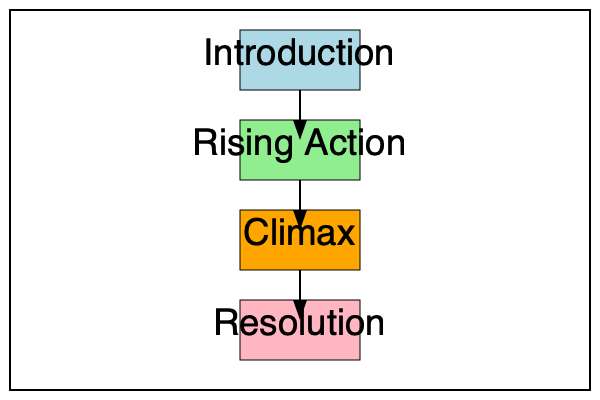Based on the flow chart provided, which storytelling element is missing from the classic narrative structure, and where should it be placed to create a complete and effective storytelling framework? To answer this question, let's analyze the flow chart and compare it to the classic narrative structure:

1. The flow chart shows four elements:
   a. Introduction
   b. Rising Action
   c. Climax
   d. Resolution

2. The classic narrative structure, also known as Freytag's Pyramid or the Five-Act Structure, typically includes five main elements:
   a. Exposition (Introduction)
   b. Rising Action
   c. Climax
   d. Falling Action
   e. Resolution (Denouement)

3. Comparing the flow chart to the classic structure, we can see that the "Falling Action" element is missing.

4. In the narrative structure, Falling Action comes after the Climax and before the Resolution. It serves as a transition between the high point of the story (Climax) and its conclusion (Resolution).

5. To complete the flow chart and create an effective storytelling framework, we need to add the "Falling Action" element between "Climax" and "Resolution."

6. The Falling Action is crucial because it:
   - Shows the consequences of the climax
   - Begins to tie up loose ends in the story
   - Prepares the audience for the resolution

Therefore, to create a complete and effective storytelling structure, we should add the "Falling Action" element between "Climax" and "Resolution" in the flow chart.
Answer: Falling Action, between Climax and Resolution 